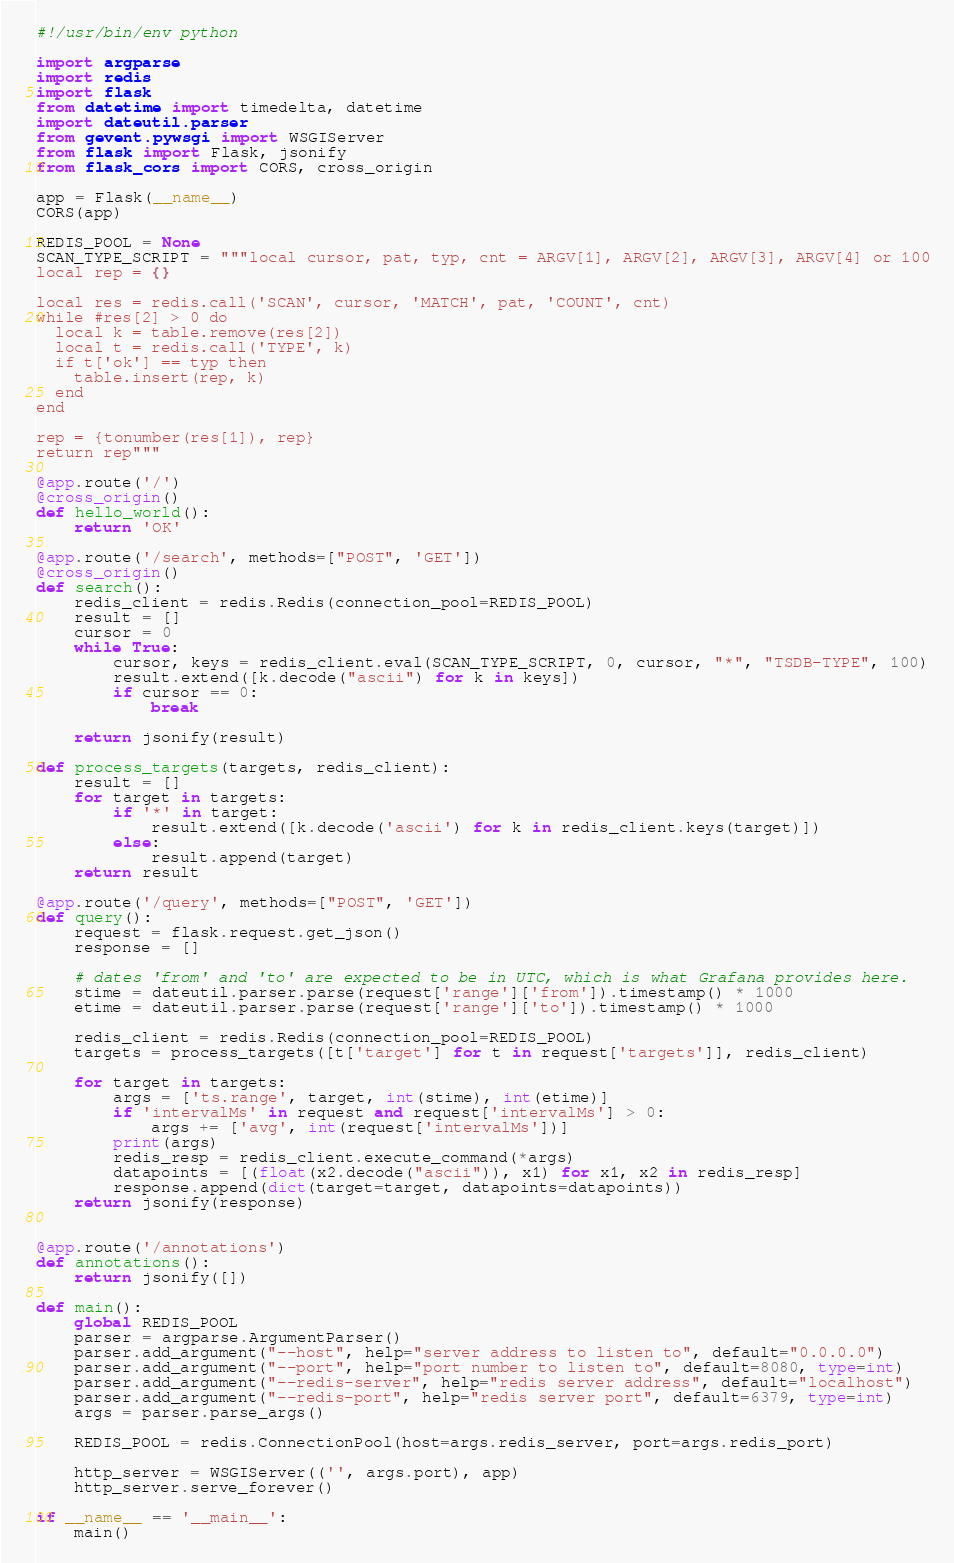Convert code to text. <code><loc_0><loc_0><loc_500><loc_500><_Python_>#!/usr/bin/env python

import argparse
import redis
import flask
from datetime import timedelta, datetime
import dateutil.parser
from gevent.pywsgi import WSGIServer
from flask import Flask, jsonify
from flask_cors import CORS, cross_origin

app = Flask(__name__)
CORS(app)

REDIS_POOL = None
SCAN_TYPE_SCRIPT = """local cursor, pat, typ, cnt = ARGV[1], ARGV[2], ARGV[3], ARGV[4] or 100
local rep = {}

local res = redis.call('SCAN', cursor, 'MATCH', pat, 'COUNT', cnt)
while #res[2] > 0 do
  local k = table.remove(res[2])
  local t = redis.call('TYPE', k)
  if t['ok'] == typ then
    table.insert(rep, k)
  end
end

rep = {tonumber(res[1]), rep}
return rep"""

@app.route('/')
@cross_origin()
def hello_world():
    return 'OK'

@app.route('/search', methods=["POST", 'GET'])
@cross_origin()
def search():
    redis_client = redis.Redis(connection_pool=REDIS_POOL)
    result = []
    cursor = 0
    while True:
        cursor, keys = redis_client.eval(SCAN_TYPE_SCRIPT, 0, cursor, "*", "TSDB-TYPE", 100)
        result.extend([k.decode("ascii") for k in keys])
        if cursor == 0:
            break

    return jsonify(result)

def process_targets(targets, redis_client):
    result = []
    for target in targets:
        if '*' in target:
            result.extend([k.decode('ascii') for k in redis_client.keys(target)])
        else:
            result.append(target)
    return result

@app.route('/query', methods=["POST", 'GET'])
def query():
    request = flask.request.get_json()
    response = []

    # dates 'from' and 'to' are expected to be in UTC, which is what Grafana provides here.
    stime = dateutil.parser.parse(request['range']['from']).timestamp() * 1000
    etime = dateutil.parser.parse(request['range']['to']).timestamp() * 1000

    redis_client = redis.Redis(connection_pool=REDIS_POOL)
    targets = process_targets([t['target'] for t in request['targets']], redis_client)

    for target in targets:
        args = ['ts.range', target, int(stime), int(etime)]
        if 'intervalMs' in request and request['intervalMs'] > 0:
            args += ['avg', int(request['intervalMs'])]
        print(args)
        redis_resp = redis_client.execute_command(*args)
        datapoints = [(float(x2.decode("ascii")), x1) for x1, x2 in redis_resp]
        response.append(dict(target=target, datapoints=datapoints))
    return jsonify(response)


@app.route('/annotations')
def annotations():
    return jsonify([])

def main():
    global REDIS_POOL
    parser = argparse.ArgumentParser()
    parser.add_argument("--host", help="server address to listen to", default="0.0.0.0")
    parser.add_argument("--port", help="port number to listen to", default=8080, type=int)
    parser.add_argument("--redis-server", help="redis server address", default="localhost")
    parser.add_argument("--redis-port", help="redis server port", default=6379, type=int)
    args = parser.parse_args()

    REDIS_POOL = redis.ConnectionPool(host=args.redis_server, port=args.redis_port)

    http_server = WSGIServer(('', args.port), app)
    http_server.serve_forever()

if __name__ == '__main__':
    main()
</code> 